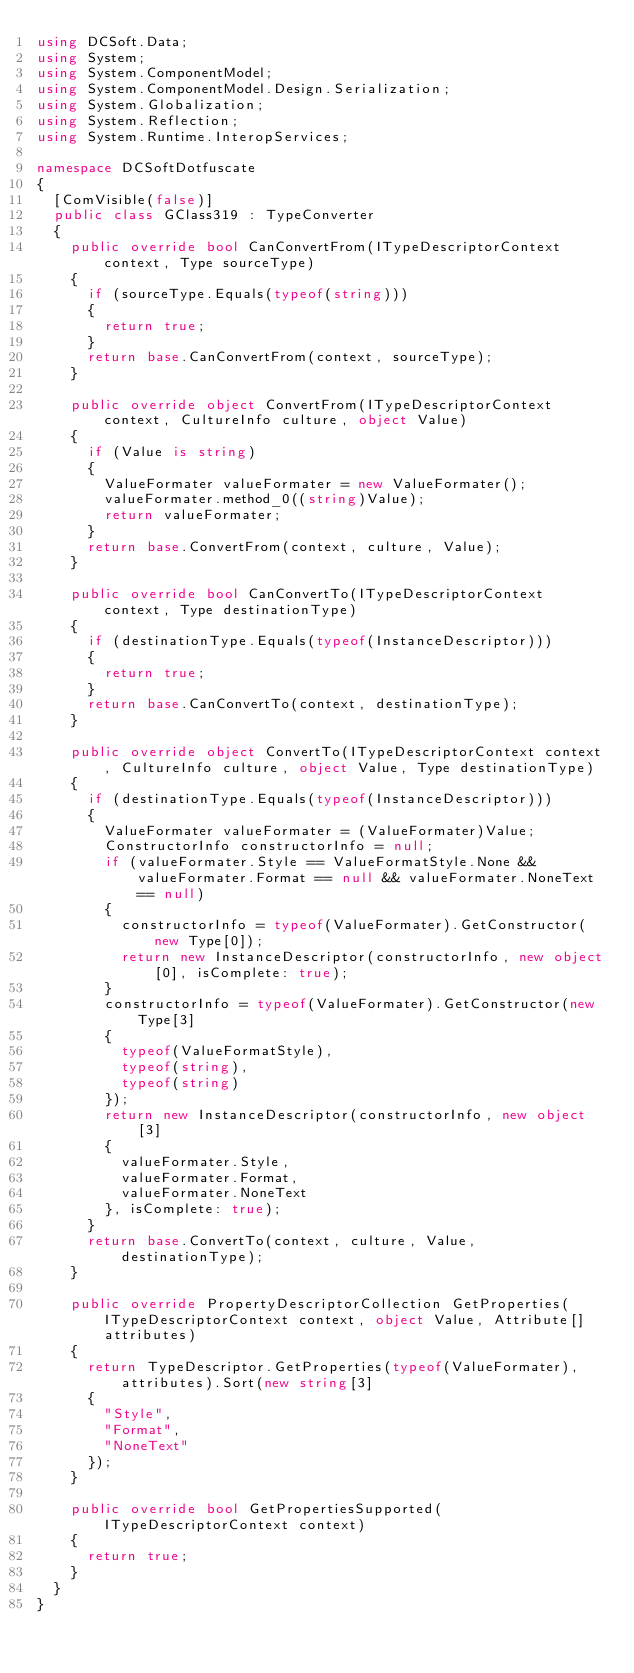Convert code to text. <code><loc_0><loc_0><loc_500><loc_500><_C#_>using DCSoft.Data;
using System;
using System.ComponentModel;
using System.ComponentModel.Design.Serialization;
using System.Globalization;
using System.Reflection;
using System.Runtime.InteropServices;

namespace DCSoftDotfuscate
{
	[ComVisible(false)]
	public class GClass319 : TypeConverter
	{
		public override bool CanConvertFrom(ITypeDescriptorContext context, Type sourceType)
		{
			if (sourceType.Equals(typeof(string)))
			{
				return true;
			}
			return base.CanConvertFrom(context, sourceType);
		}

		public override object ConvertFrom(ITypeDescriptorContext context, CultureInfo culture, object Value)
		{
			if (Value is string)
			{
				ValueFormater valueFormater = new ValueFormater();
				valueFormater.method_0((string)Value);
				return valueFormater;
			}
			return base.ConvertFrom(context, culture, Value);
		}

		public override bool CanConvertTo(ITypeDescriptorContext context, Type destinationType)
		{
			if (destinationType.Equals(typeof(InstanceDescriptor)))
			{
				return true;
			}
			return base.CanConvertTo(context, destinationType);
		}

		public override object ConvertTo(ITypeDescriptorContext context, CultureInfo culture, object Value, Type destinationType)
		{
			if (destinationType.Equals(typeof(InstanceDescriptor)))
			{
				ValueFormater valueFormater = (ValueFormater)Value;
				ConstructorInfo constructorInfo = null;
				if (valueFormater.Style == ValueFormatStyle.None && valueFormater.Format == null && valueFormater.NoneText == null)
				{
					constructorInfo = typeof(ValueFormater).GetConstructor(new Type[0]);
					return new InstanceDescriptor(constructorInfo, new object[0], isComplete: true);
				}
				constructorInfo = typeof(ValueFormater).GetConstructor(new Type[3]
				{
					typeof(ValueFormatStyle),
					typeof(string),
					typeof(string)
				});
				return new InstanceDescriptor(constructorInfo, new object[3]
				{
					valueFormater.Style,
					valueFormater.Format,
					valueFormater.NoneText
				}, isComplete: true);
			}
			return base.ConvertTo(context, culture, Value, destinationType);
		}

		public override PropertyDescriptorCollection GetProperties(ITypeDescriptorContext context, object Value, Attribute[] attributes)
		{
			return TypeDescriptor.GetProperties(typeof(ValueFormater), attributes).Sort(new string[3]
			{
				"Style",
				"Format",
				"NoneText"
			});
		}

		public override bool GetPropertiesSupported(ITypeDescriptorContext context)
		{
			return true;
		}
	}
}
</code> 